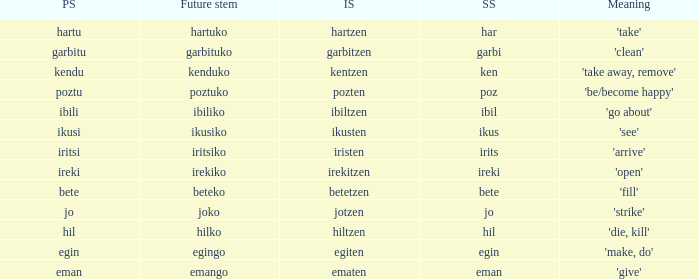What is the number for future stem for poztu? 1.0. 